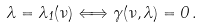Convert formula to latex. <formula><loc_0><loc_0><loc_500><loc_500>\lambda = \lambda _ { 1 } ( \nu ) \Longleftrightarrow \gamma ( \nu , \lambda ) = 0 \, .</formula> 